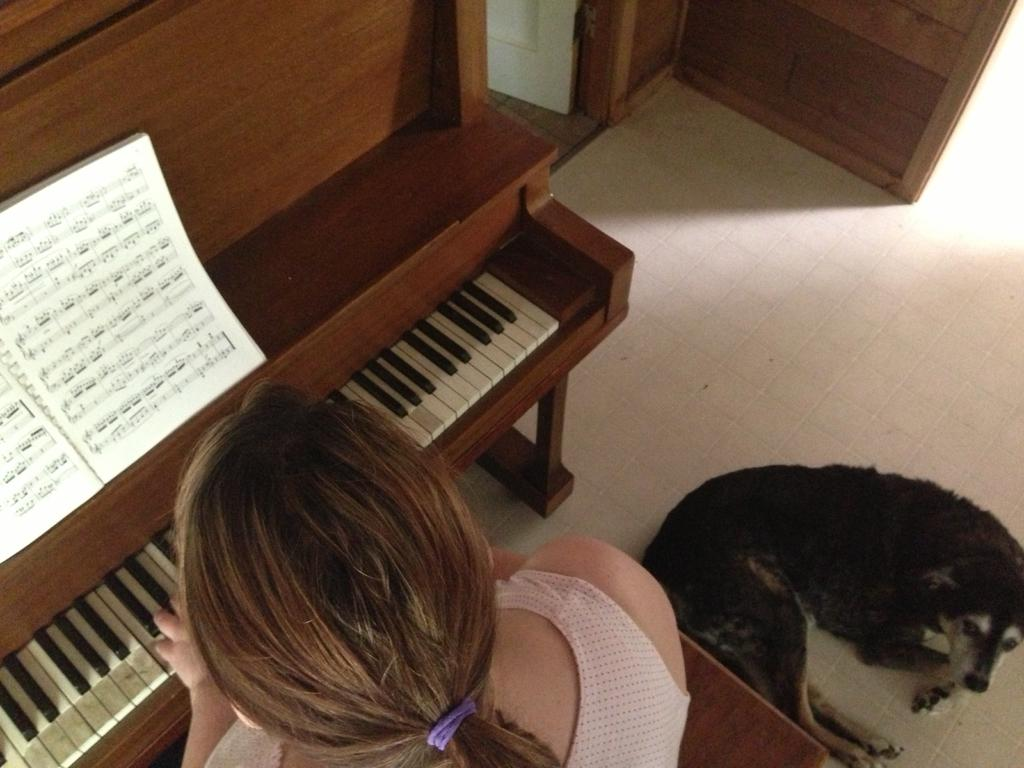Who is the main subject in the image? There is a woman in the image. What is the woman doing in the image? The woman is sitting in a chair and playing the piano. What other objects or items can be seen in the image? There is a book in the image. Can you describe the dog in the image? The dog is in the background of the image and is on the floor. What question is the woman asking the dog in the image? There is no indication in the image that the woman is asking the dog a question. What is the weight of the dog in the image? The weight of the dog cannot be determined from the image. 